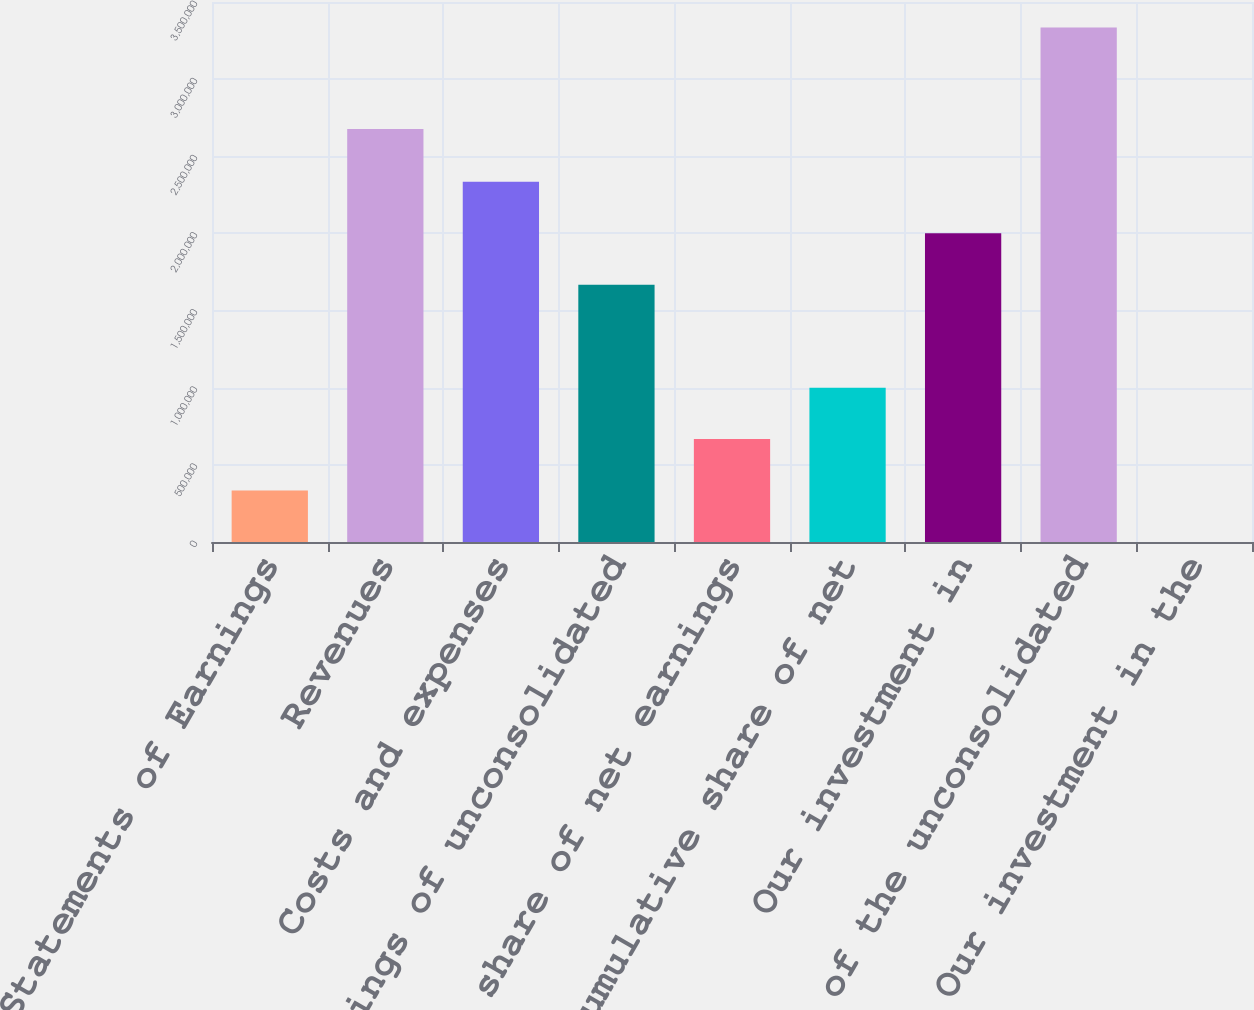Convert chart to OTSL. <chart><loc_0><loc_0><loc_500><loc_500><bar_chart><fcel>Statements of Earnings<fcel>Revenues<fcel>Costs and expenses<fcel>Net earnings of unconsolidated<fcel>Our share of net earnings<fcel>Our cumulative share of net<fcel>Our investment in<fcel>Equity of the unconsolidated<fcel>Our investment in the<nl><fcel>333490<fcel>2.67663e+06<fcel>2.3342e+06<fcel>1.66729e+06<fcel>666941<fcel>1.00039e+06<fcel>2.00074e+06<fcel>3.33455e+06<fcel>38.5<nl></chart> 